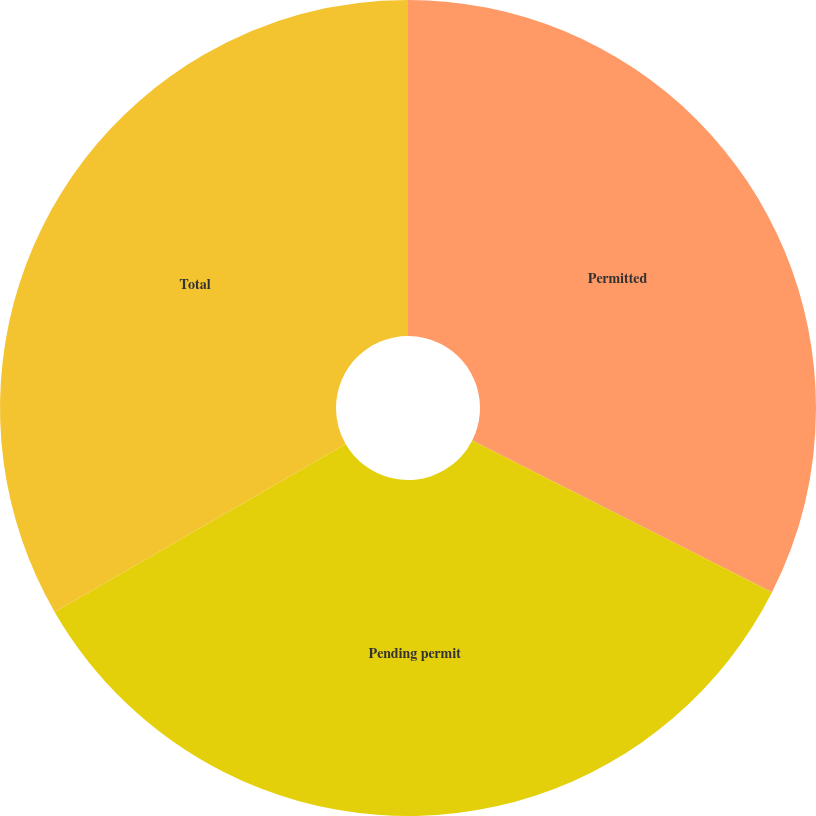Convert chart to OTSL. <chart><loc_0><loc_0><loc_500><loc_500><pie_chart><fcel>Permitted<fcel>Pending permit<fcel>Total<nl><fcel>32.46%<fcel>34.21%<fcel>33.33%<nl></chart> 